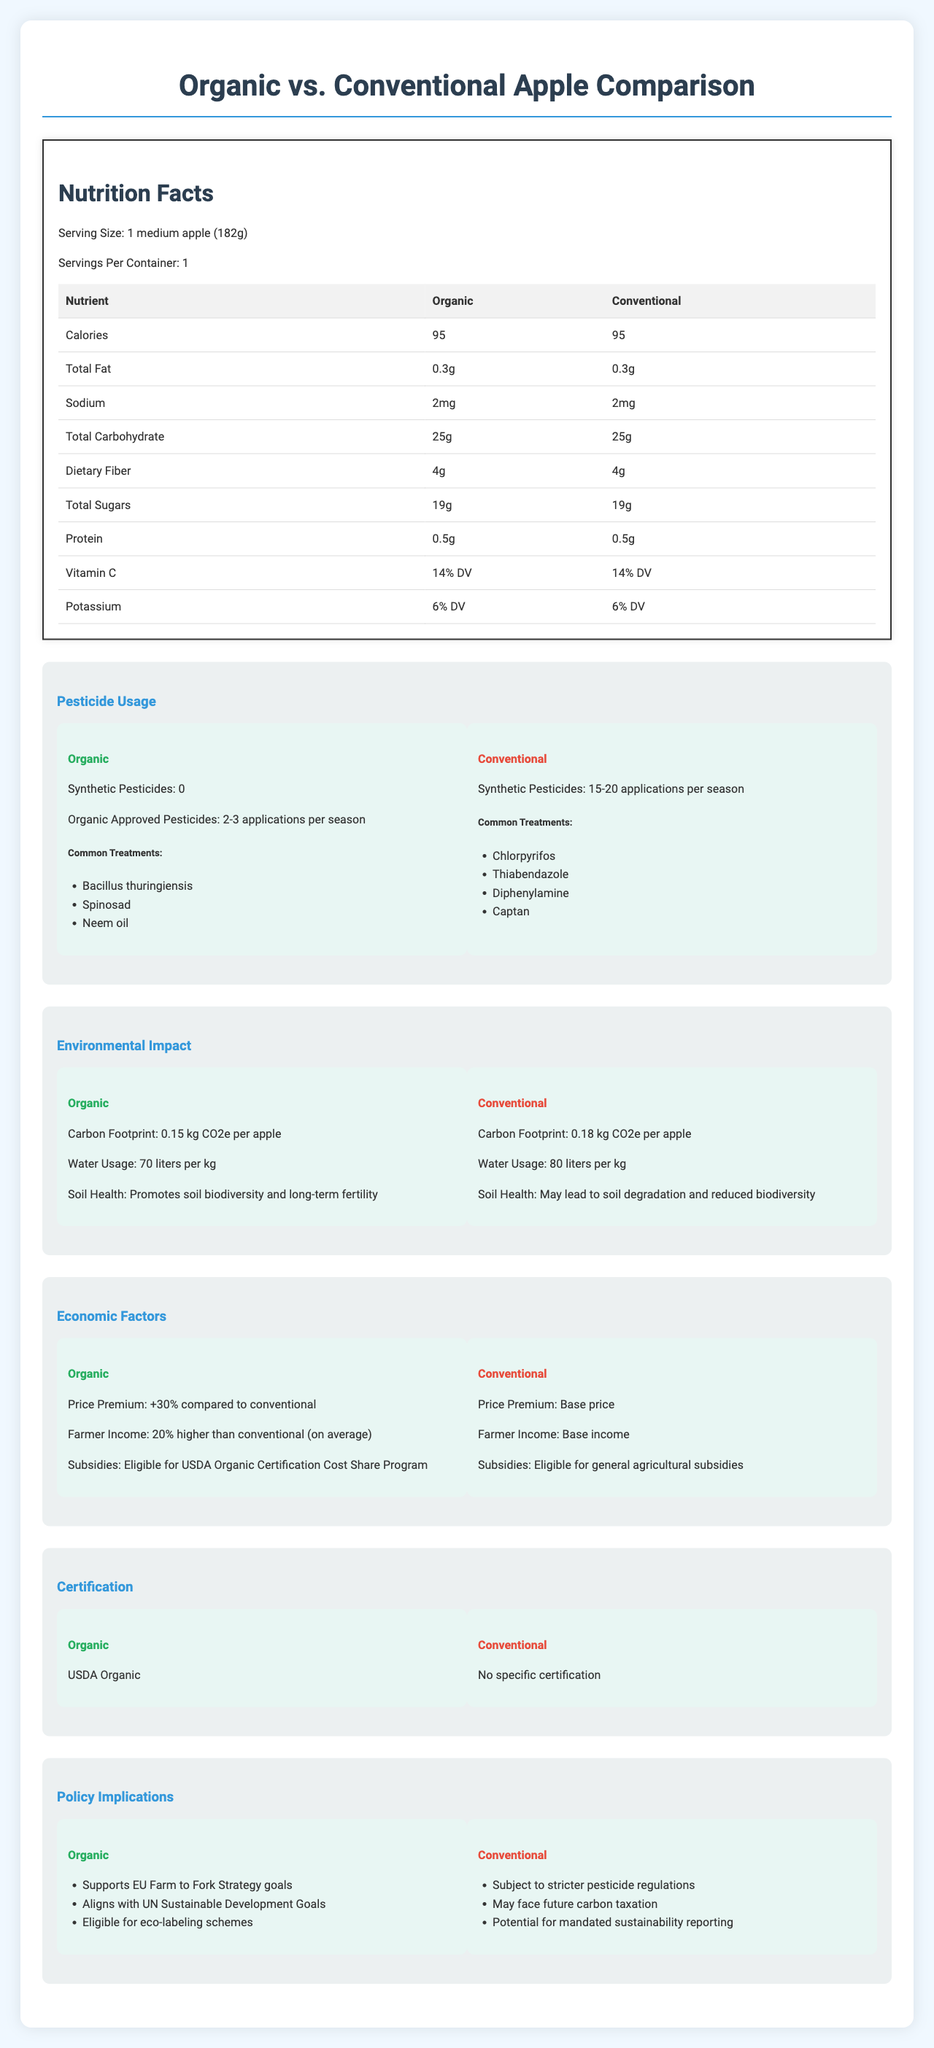what is the serving size for the apples? The serving size is listed as "1 medium apple (182g)" at the top of the nutrition label.
Answer: 1 medium apple (182g) how many calories does a conventional apple have? The document states that a conventional apple contains 95 calories.
Answer: 95 what is the amount of dietary fiber in an organic apple? The table in the nutrition facts section shows that an organic apple contains 4g of dietary fiber.
Answer: 4g does the document provide information about synthetic pesticide usage in organic apples? The pesticide usage section indicates that no synthetic pesticides are used in organic apples.
Answer: Yes how many applications of organic approved pesticides are used per season for organic apples? The document specifies that organic approved pesticides are applied 2-3 times per season for organic apples.
Answer: 2-3 applications per season compare the carbon footprint of organic vs. conventional apples. The environmental impact section displays these values in the comparison of carbon footprint for organic and conventional apples.
Answer: Organic: 0.15 kg CO2e per apple, Conventional: 0.18 kg CO2e per apple which type of apple uses more water per kilogram? The environmental impact section shows that conventional apples use 80 liters of water per kilogram, while organic apples use 70 liters per kilogram.
Answer: Conventional what is the price premium for organic apples compared to conventional ones? According to the economic factors section, organic apples have a price premium of +30% compared to conventional apples.
Answer: +30% which of the following is an organic approved pesticide used on organic apples? A. Chlorpyrifos B. Bacillus thuringiensis C. Thiabendazole D. Diphenylamine The pesticide usage section under organic apples lists "Bacillus thuringiensis" as a common treatment.
Answer: B. Bacillus thuringiensis True or False: Organic farming promotes soil biodiversity and long-term fertility, while conventional farming may lead to soil degradation and reduced biodiversity. The environmental impact section states these effects on soil health for organic and conventional farming.
Answer: True which policy goal does organic farming support? A. EU Farm to Fork Strategy goals B. Stricter pesticide regulations C. Future carbon taxation The policy implications section lists "Supports EU Farm to Fork Strategy goals" under the organic category.
Answer: A. EU Farm to Fork Strategy goals does conventional apple farming align with any UN Sustainable Development Goals? The document does not mention any alignment of conventional apple farming with UN Sustainable Development Goals.
Answer: No summarize the comparative analysis presented in the document. The detailed explanation involves comparing each aspect where organic apples use fewer synthetic pesticides, have a lower carbon footprint, and promote soil health, whereas conventional apples might lead to soil degradation and use more water. Economic factors favor organic farming in terms of price and farmer income, with specific certifications and policy implications supporting sustainability.
Answer: The document compares organic and conventional apples in terms of nutrition, pesticide usage, environmental impact, economic factors, certification, and policy implications. Both types have similar nutritional contents, but differ significantly in pesticide usage, environmental footprint, and economic aspects, with organic apples generally being more sustainable and costlier. what percentage of the daily value (DV) of vitamin C does a conventional apple provide? The nutrition facts table shows that both organic and conventional apples provide 14% of the daily value for vitamin C.
Answer: 14% DV how many common pesticide treatments are listed for conventional apples? The pesticide usage section lists four common pesticide treatments for conventional apples: Chlorpyrifos, Thiabendazole, Diphenylamine, and Captan.
Answer: Four is there information about how apples are produced from a specific region? The document does not provide any regional production details for the apples.
Answer: Not enough information 